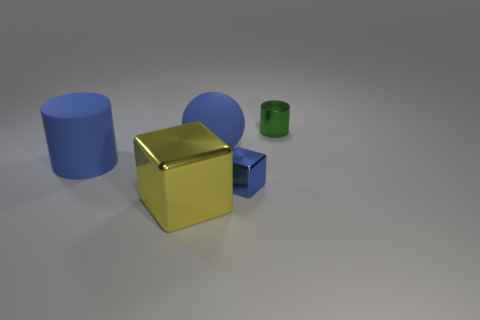Is the material of the yellow thing the same as the green thing that is to the right of the large rubber cylinder?
Your response must be concise. Yes. The shiny thing that is the same color as the big rubber cylinder is what shape?
Provide a short and direct response. Cube. How many other matte balls have the same size as the matte sphere?
Provide a short and direct response. 0. Are there fewer blue cylinders that are right of the tiny green object than small green shiny cylinders?
Provide a succinct answer. Yes. How many yellow shiny cubes are on the right side of the big metallic cube?
Provide a short and direct response. 0. How big is the cylinder right of the big object in front of the tiny thing that is in front of the green metallic cylinder?
Make the answer very short. Small. Do the large shiny object and the tiny green object to the right of the blue metallic block have the same shape?
Make the answer very short. No. There is a yellow object that is the same material as the small cylinder; what size is it?
Your response must be concise. Large. Are there any other things that have the same color as the large rubber sphere?
Make the answer very short. Yes. What material is the small object that is in front of the small object that is to the right of the tiny metallic thing that is in front of the green thing made of?
Provide a short and direct response. Metal. 